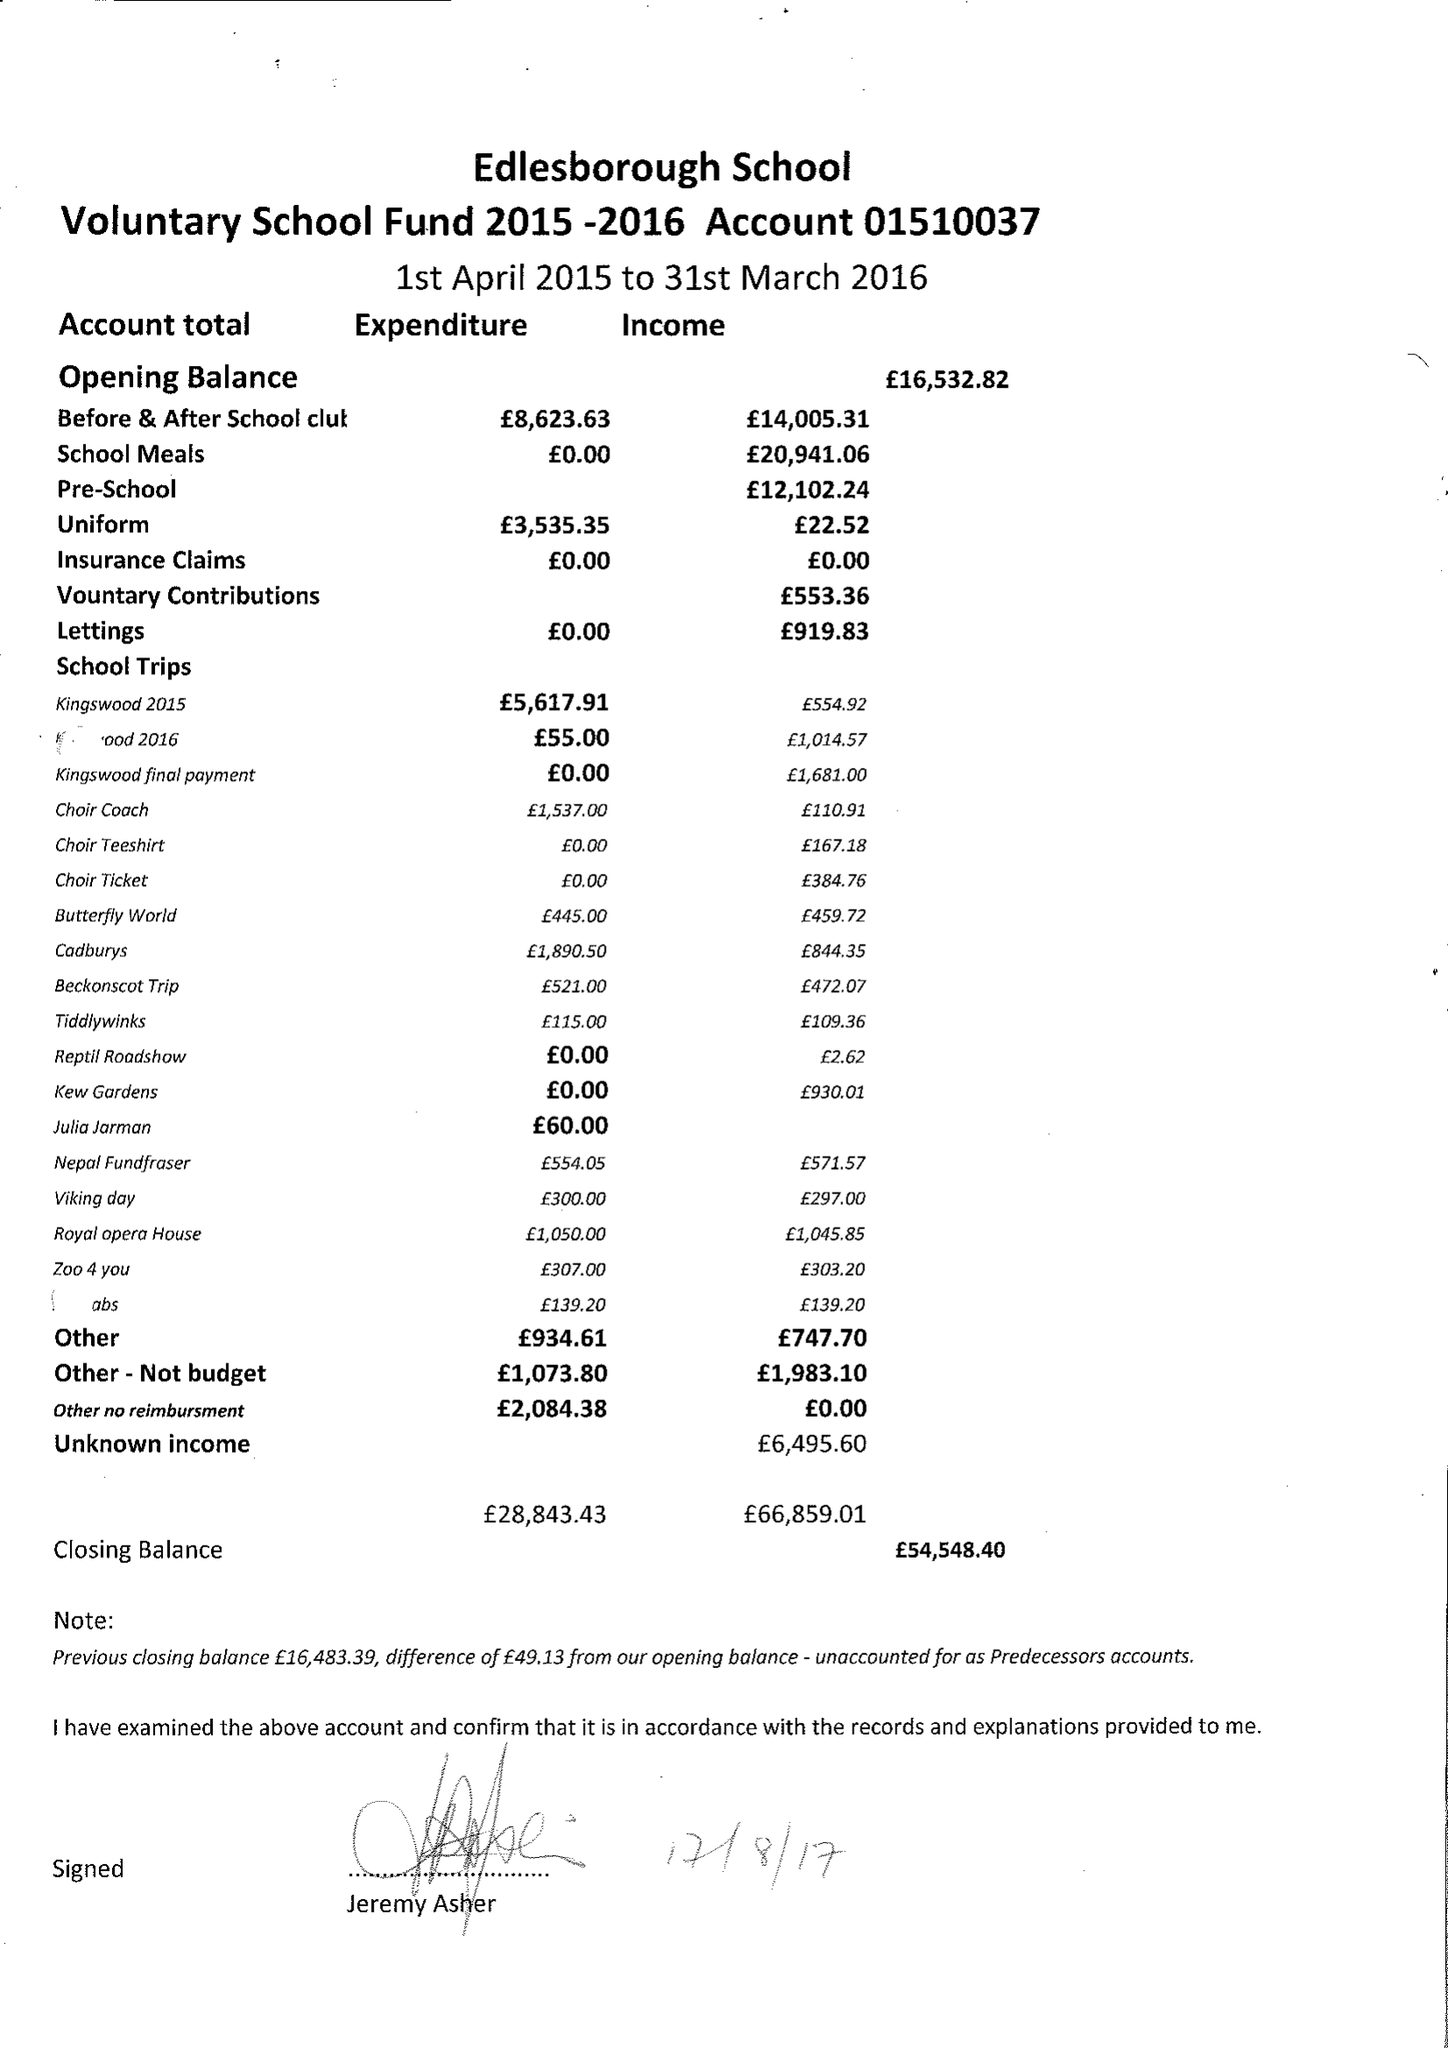What is the value for the spending_annually_in_british_pounds?
Answer the question using a single word or phrase. 28843.43 